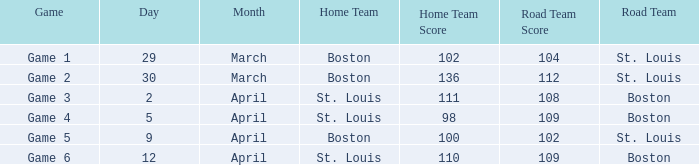What is the Result of the Game on April 9? 100-102. 